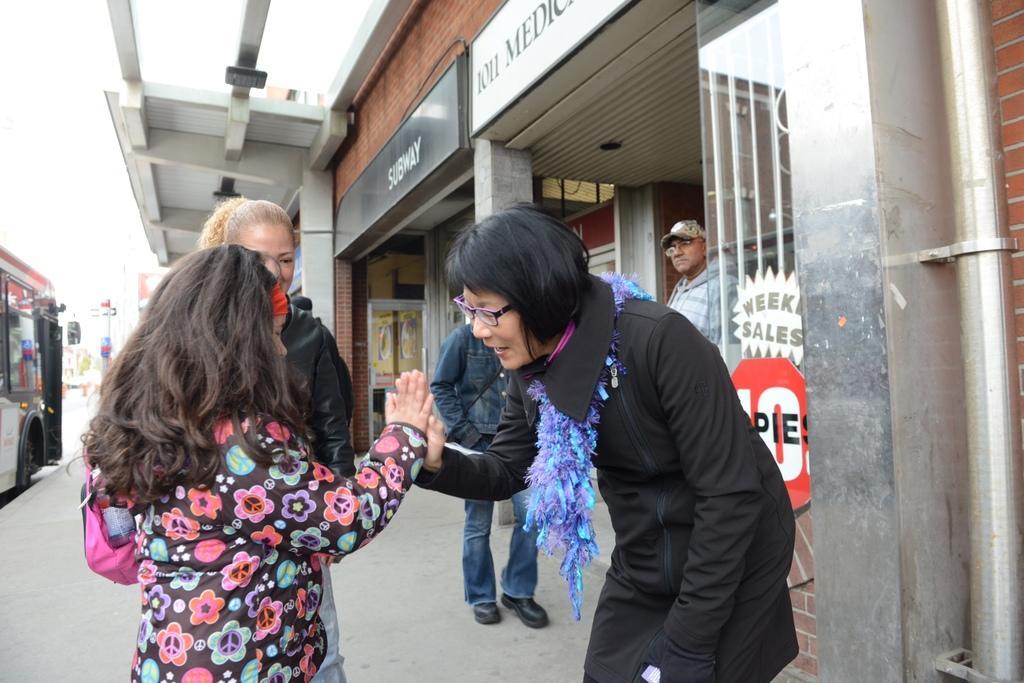Please provide a concise description of this image. In this picture we can observe some people standing on the footpath. There are women, men and a girl. On the left side there is a bus on the road. We can observe a building on the right side. 